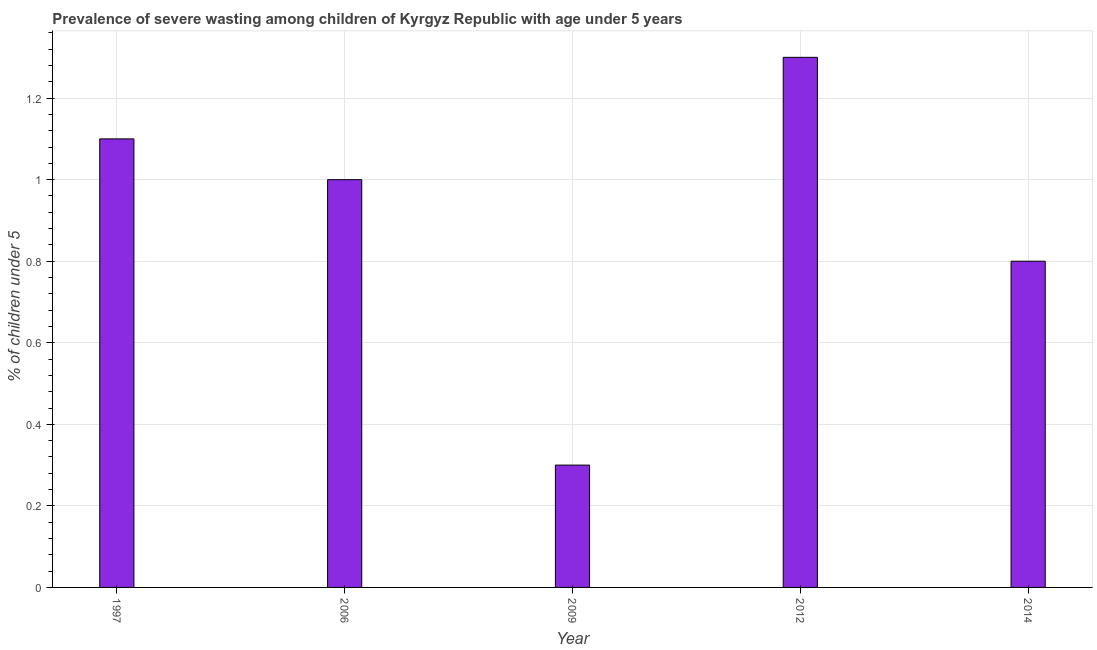What is the title of the graph?
Provide a short and direct response. Prevalence of severe wasting among children of Kyrgyz Republic with age under 5 years. What is the label or title of the X-axis?
Your response must be concise. Year. What is the label or title of the Y-axis?
Ensure brevity in your answer.   % of children under 5. Across all years, what is the maximum prevalence of severe wasting?
Give a very brief answer. 1.3. Across all years, what is the minimum prevalence of severe wasting?
Your response must be concise. 0.3. In which year was the prevalence of severe wasting minimum?
Your response must be concise. 2009. What is the sum of the prevalence of severe wasting?
Your response must be concise. 4.5. What is the difference between the prevalence of severe wasting in 1997 and 2012?
Keep it short and to the point. -0.2. What is the ratio of the prevalence of severe wasting in 2009 to that in 2014?
Your response must be concise. 0.38. Is the difference between the prevalence of severe wasting in 1997 and 2014 greater than the difference between any two years?
Ensure brevity in your answer.  No. How many bars are there?
Ensure brevity in your answer.  5. Are all the bars in the graph horizontal?
Your answer should be compact. No. How many years are there in the graph?
Provide a succinct answer. 5. Are the values on the major ticks of Y-axis written in scientific E-notation?
Make the answer very short. No. What is the  % of children under 5 in 1997?
Provide a short and direct response. 1.1. What is the  % of children under 5 of 2009?
Provide a succinct answer. 0.3. What is the  % of children under 5 of 2012?
Make the answer very short. 1.3. What is the  % of children under 5 of 2014?
Make the answer very short. 0.8. What is the difference between the  % of children under 5 in 1997 and 2006?
Your answer should be very brief. 0.1. What is the difference between the  % of children under 5 in 1997 and 2009?
Make the answer very short. 0.8. What is the difference between the  % of children under 5 in 1997 and 2012?
Give a very brief answer. -0.2. What is the difference between the  % of children under 5 in 2006 and 2009?
Offer a very short reply. 0.7. What is the difference between the  % of children under 5 in 2009 and 2012?
Ensure brevity in your answer.  -1. What is the difference between the  % of children under 5 in 2009 and 2014?
Keep it short and to the point. -0.5. What is the difference between the  % of children under 5 in 2012 and 2014?
Offer a terse response. 0.5. What is the ratio of the  % of children under 5 in 1997 to that in 2009?
Your response must be concise. 3.67. What is the ratio of the  % of children under 5 in 1997 to that in 2012?
Your answer should be compact. 0.85. What is the ratio of the  % of children under 5 in 1997 to that in 2014?
Give a very brief answer. 1.38. What is the ratio of the  % of children under 5 in 2006 to that in 2009?
Give a very brief answer. 3.33. What is the ratio of the  % of children under 5 in 2006 to that in 2012?
Provide a short and direct response. 0.77. What is the ratio of the  % of children under 5 in 2009 to that in 2012?
Your answer should be compact. 0.23. What is the ratio of the  % of children under 5 in 2009 to that in 2014?
Your answer should be compact. 0.38. What is the ratio of the  % of children under 5 in 2012 to that in 2014?
Offer a very short reply. 1.62. 